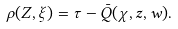Convert formula to latex. <formula><loc_0><loc_0><loc_500><loc_500>\rho ( Z , \xi ) = \tau - \bar { Q } ( \chi , z , w ) .</formula> 